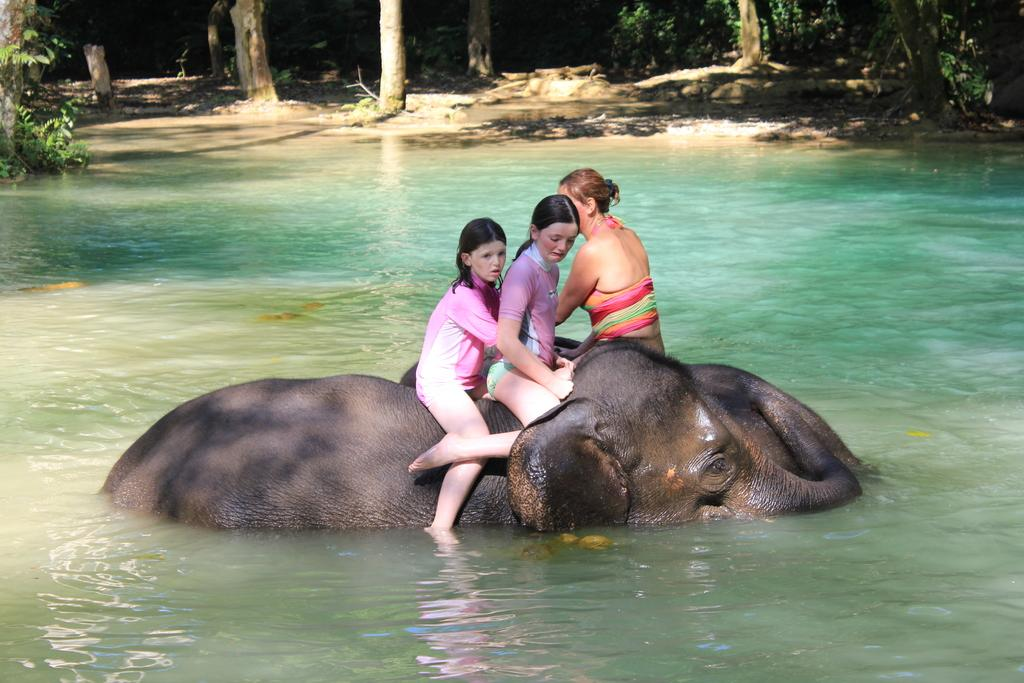How many people are in the image? There are three persons in the image. What are the persons doing in the image? The persons are sitting on elephants. Where are the elephants located in the image? The elephants are in the water. What can be seen in the background of the image? There are trees visible in the background of the image. What type of selection process is being carried out by the minister in the image? There is no minister or selection process present in the image. What is the reason for the protest in the image? There is no protest or related activity depicted in the image. 